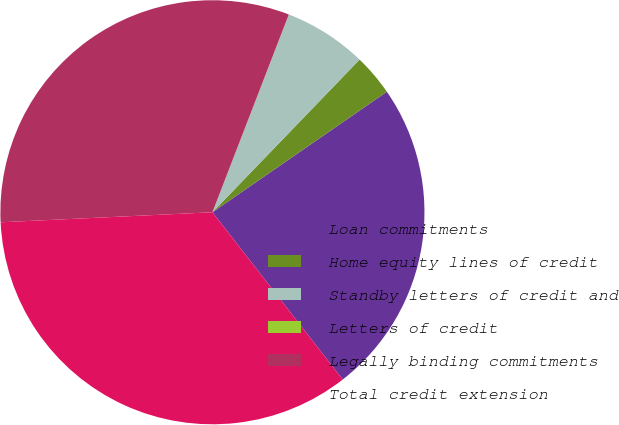Convert chart. <chart><loc_0><loc_0><loc_500><loc_500><pie_chart><fcel>Loan commitments<fcel>Home equity lines of credit<fcel>Standby letters of credit and<fcel>Letters of credit<fcel>Legally binding commitments<fcel>Total credit extension<nl><fcel>24.09%<fcel>3.17%<fcel>6.33%<fcel>0.01%<fcel>31.62%<fcel>34.78%<nl></chart> 